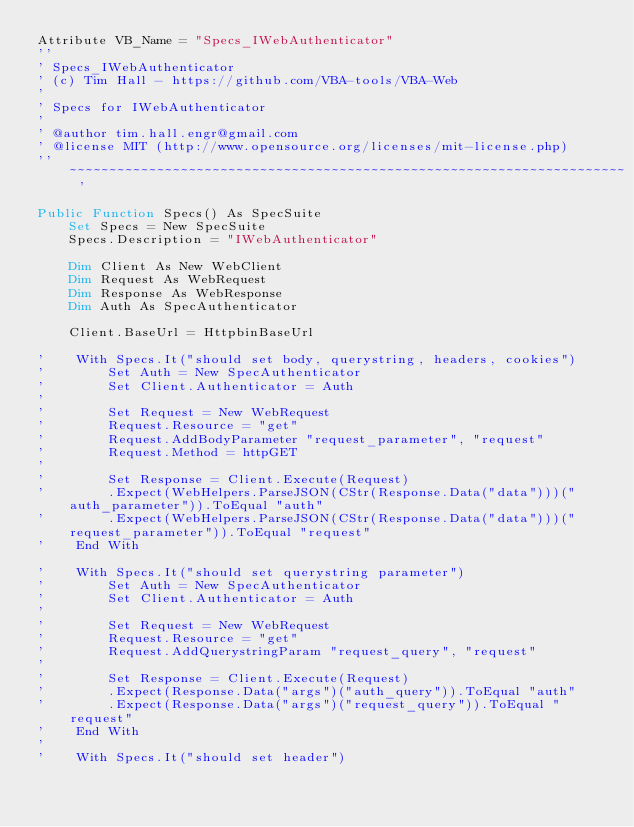<code> <loc_0><loc_0><loc_500><loc_500><_VisualBasic_>Attribute VB_Name = "Specs_IWebAuthenticator"
''
' Specs_IWebAuthenticator
' (c) Tim Hall - https://github.com/VBA-tools/VBA-Web
'
' Specs for IWebAuthenticator
'
' @author tim.hall.engr@gmail.com
' @license MIT (http://www.opensource.org/licenses/mit-license.php)
'' ~~~~~~~~~~~~~~~~~~~~~~~~~~~~~~~~~~~~~~~~~~~~~~~~~~~~~~~~~~~~~~~~~~~~~~ '

Public Function Specs() As SpecSuite
    Set Specs = New SpecSuite
    Specs.Description = "IWebAuthenticator"
    
    Dim Client As New WebClient
    Dim Request As WebRequest
    Dim Response As WebResponse
    Dim Auth As SpecAuthenticator
    
    Client.BaseUrl = HttpbinBaseUrl
    
'    With Specs.It("should set body, querystring, headers, cookies")
'        Set Auth = New SpecAuthenticator
'        Set Client.Authenticator = Auth
'
'        Set Request = New WebRequest
'        Request.Resource = "get"
'        Request.AddBodyParameter "request_parameter", "request"
'        Request.Method = httpGET
'
'        Set Response = Client.Execute(Request)
'        .Expect(WebHelpers.ParseJSON(CStr(Response.Data("data")))("auth_parameter")).ToEqual "auth"
'        .Expect(WebHelpers.ParseJSON(CStr(Response.Data("data")))("request_parameter")).ToEqual "request"
'    End With

'    With Specs.It("should set querystring parameter")
'        Set Auth = New SpecAuthenticator
'        Set Client.Authenticator = Auth
'
'        Set Request = New WebRequest
'        Request.Resource = "get"
'        Request.AddQuerystringParam "request_query", "request"
'
'        Set Response = Client.Execute(Request)
'        .Expect(Response.Data("args")("auth_query")).ToEqual "auth"
'        .Expect(Response.Data("args")("request_query")).ToEqual "request"
'    End With
'
'    With Specs.It("should set header")</code> 